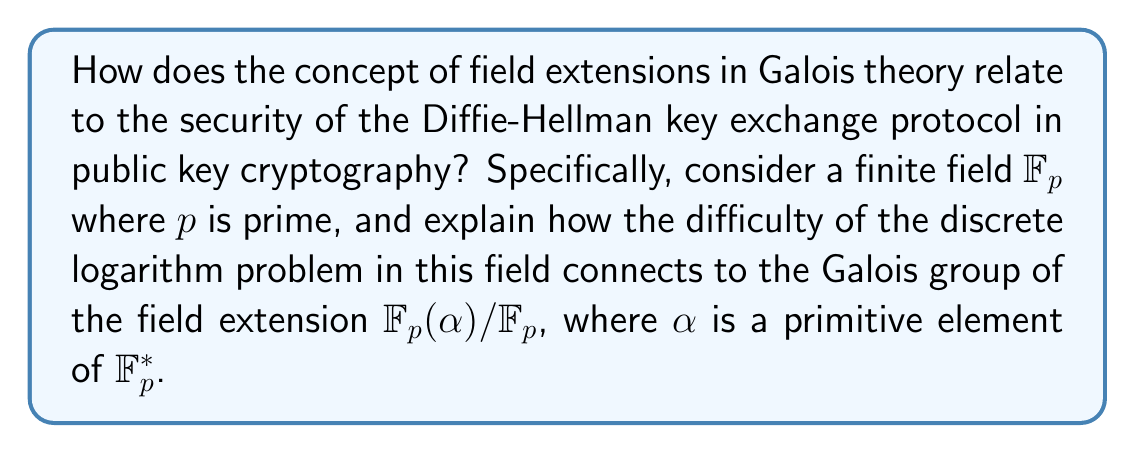Teach me how to tackle this problem. To understand the connection between Galois theory and the Diffie-Hellman key exchange protocol, we'll follow these steps:

1) First, recall that the Diffie-Hellman protocol operates in a finite field $\mathbb{F}_p$, where $p$ is prime. The security of this protocol relies on the difficulty of the discrete logarithm problem in this field.

2) In Galois theory, we study field extensions. Consider the extension $\mathbb{F}_p(\alpha) / \mathbb{F}_p$, where $\alpha$ is a primitive element of $\mathbb{F}_p^*$. This means that $\alpha$ generates the multiplicative group $\mathbb{F}_p^*$.

3) The Galois group $Gal(\mathbb{F}_p(\alpha) / \mathbb{F}_p)$ consists of automorphisms of $\mathbb{F}_p(\alpha)$ that fix $\mathbb{F}_p$. These automorphisms permute the roots of the minimal polynomial of $\alpha$ over $\mathbb{F}_p$.

4) The order of this Galois group is equal to the degree of the extension $[\mathbb{F}_p(\alpha) : \mathbb{F}_p]$, which is $p-1$ since $\alpha$ is a primitive element.

5) Now, consider the discrete logarithm problem: given $g$ and $g^x$ in $\mathbb{F}_p^*$, find $x$. This is equivalent to finding the automorphism in $Gal(\mathbb{F}_p(\alpha) / \mathbb{F}_p)$ that maps $\alpha$ to $\alpha^x$.

6) The difficulty of the discrete logarithm problem is related to the structure of this Galois group. If we could efficiently compute the action of elements in the Galois group, we could solve the discrete logarithm problem.

7) However, the Galois group of this extension is isomorphic to the multiplicative group $\mathbb{F}_p^*$, which is cyclic of order $p-1$. The complexity of operations in this group is what provides the security for the Diffie-Hellman protocol.

8) From an automata theory perspective, we can view the Galois group as a state machine, where each state corresponds to an automorphism, and transitions correspond to composition of automorphisms. The discrete logarithm problem is then equivalent to finding a specific path in this automaton.

Therefore, the security of the Diffie-Hellman protocol is intrinsically linked to the structure and properties of the Galois group of the field extension $\mathbb{F}_p(\alpha) / \mathbb{F}_p$, demonstrating a deep connection between Galois theory and public key cryptography.
Answer: The difficulty of the discrete logarithm problem in $\mathbb{F}_p^*$ corresponds to the complexity of computing specific automorphisms in $Gal(\mathbb{F}_p(\alpha) / \mathbb{F}_p)$. 